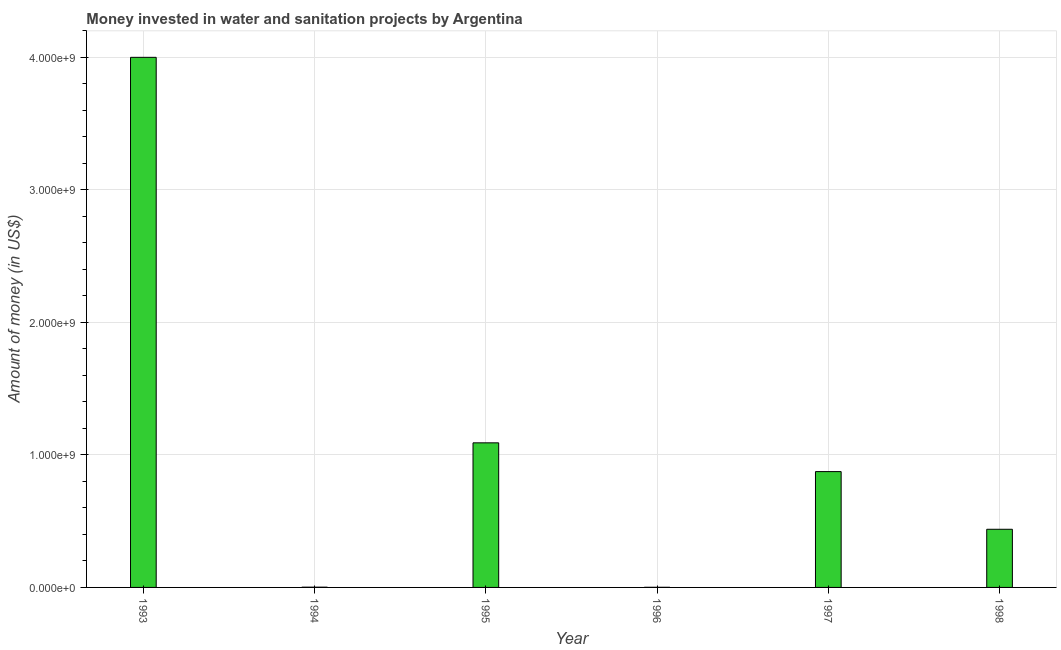Does the graph contain any zero values?
Provide a short and direct response. No. What is the title of the graph?
Your response must be concise. Money invested in water and sanitation projects by Argentina. What is the label or title of the X-axis?
Offer a very short reply. Year. What is the label or title of the Y-axis?
Ensure brevity in your answer.  Amount of money (in US$). What is the investment in 1998?
Your response must be concise. 4.39e+08. Across all years, what is the maximum investment?
Your response must be concise. 4.00e+09. In which year was the investment minimum?
Make the answer very short. 1996. What is the sum of the investment?
Make the answer very short. 6.41e+09. What is the difference between the investment in 1994 and 1995?
Your answer should be very brief. -1.09e+09. What is the average investment per year?
Keep it short and to the point. 1.07e+09. What is the median investment?
Provide a short and direct response. 6.56e+08. In how many years, is the investment greater than 3200000000 US$?
Your response must be concise. 1. Do a majority of the years between 1994 and 1996 (inclusive) have investment greater than 200000000 US$?
Offer a very short reply. No. What is the ratio of the investment in 1995 to that in 1997?
Your response must be concise. 1.25. Is the difference between the investment in 1997 and 1998 greater than the difference between any two years?
Keep it short and to the point. No. What is the difference between the highest and the second highest investment?
Ensure brevity in your answer.  2.91e+09. Is the sum of the investment in 1995 and 1998 greater than the maximum investment across all years?
Keep it short and to the point. No. What is the difference between the highest and the lowest investment?
Provide a succinct answer. 4.00e+09. In how many years, is the investment greater than the average investment taken over all years?
Your answer should be compact. 2. How many bars are there?
Offer a terse response. 6. How many years are there in the graph?
Give a very brief answer. 6. What is the difference between two consecutive major ticks on the Y-axis?
Offer a very short reply. 1.00e+09. What is the Amount of money (in US$) in 1993?
Your answer should be compact. 4.00e+09. What is the Amount of money (in US$) in 1994?
Your answer should be very brief. 1.90e+06. What is the Amount of money (in US$) of 1995?
Keep it short and to the point. 1.09e+09. What is the Amount of money (in US$) of 1997?
Keep it short and to the point. 8.74e+08. What is the Amount of money (in US$) of 1998?
Keep it short and to the point. 4.39e+08. What is the difference between the Amount of money (in US$) in 1993 and 1994?
Keep it short and to the point. 4.00e+09. What is the difference between the Amount of money (in US$) in 1993 and 1995?
Your answer should be very brief. 2.91e+09. What is the difference between the Amount of money (in US$) in 1993 and 1996?
Give a very brief answer. 4.00e+09. What is the difference between the Amount of money (in US$) in 1993 and 1997?
Keep it short and to the point. 3.13e+09. What is the difference between the Amount of money (in US$) in 1993 and 1998?
Provide a short and direct response. 3.56e+09. What is the difference between the Amount of money (in US$) in 1994 and 1995?
Offer a terse response. -1.09e+09. What is the difference between the Amount of money (in US$) in 1994 and 1997?
Your response must be concise. -8.72e+08. What is the difference between the Amount of money (in US$) in 1994 and 1998?
Make the answer very short. -4.37e+08. What is the difference between the Amount of money (in US$) in 1995 and 1996?
Your answer should be very brief. 1.09e+09. What is the difference between the Amount of money (in US$) in 1995 and 1997?
Offer a terse response. 2.17e+08. What is the difference between the Amount of money (in US$) in 1995 and 1998?
Ensure brevity in your answer.  6.52e+08. What is the difference between the Amount of money (in US$) in 1996 and 1997?
Offer a terse response. -8.73e+08. What is the difference between the Amount of money (in US$) in 1996 and 1998?
Your response must be concise. -4.38e+08. What is the difference between the Amount of money (in US$) in 1997 and 1998?
Your answer should be compact. 4.35e+08. What is the ratio of the Amount of money (in US$) in 1993 to that in 1994?
Give a very brief answer. 2105.26. What is the ratio of the Amount of money (in US$) in 1993 to that in 1995?
Your response must be concise. 3.67. What is the ratio of the Amount of money (in US$) in 1993 to that in 1996?
Your response must be concise. 4444.44. What is the ratio of the Amount of money (in US$) in 1993 to that in 1997?
Make the answer very short. 4.58. What is the ratio of the Amount of money (in US$) in 1993 to that in 1998?
Keep it short and to the point. 9.12. What is the ratio of the Amount of money (in US$) in 1994 to that in 1995?
Keep it short and to the point. 0. What is the ratio of the Amount of money (in US$) in 1994 to that in 1996?
Give a very brief answer. 2.11. What is the ratio of the Amount of money (in US$) in 1994 to that in 1997?
Your answer should be very brief. 0. What is the ratio of the Amount of money (in US$) in 1994 to that in 1998?
Keep it short and to the point. 0. What is the ratio of the Amount of money (in US$) in 1995 to that in 1996?
Make the answer very short. 1212.22. What is the ratio of the Amount of money (in US$) in 1995 to that in 1997?
Provide a succinct answer. 1.25. What is the ratio of the Amount of money (in US$) in 1995 to that in 1998?
Your response must be concise. 2.49. What is the ratio of the Amount of money (in US$) in 1996 to that in 1997?
Keep it short and to the point. 0. What is the ratio of the Amount of money (in US$) in 1996 to that in 1998?
Make the answer very short. 0. What is the ratio of the Amount of money (in US$) in 1997 to that in 1998?
Your answer should be compact. 1.99. 